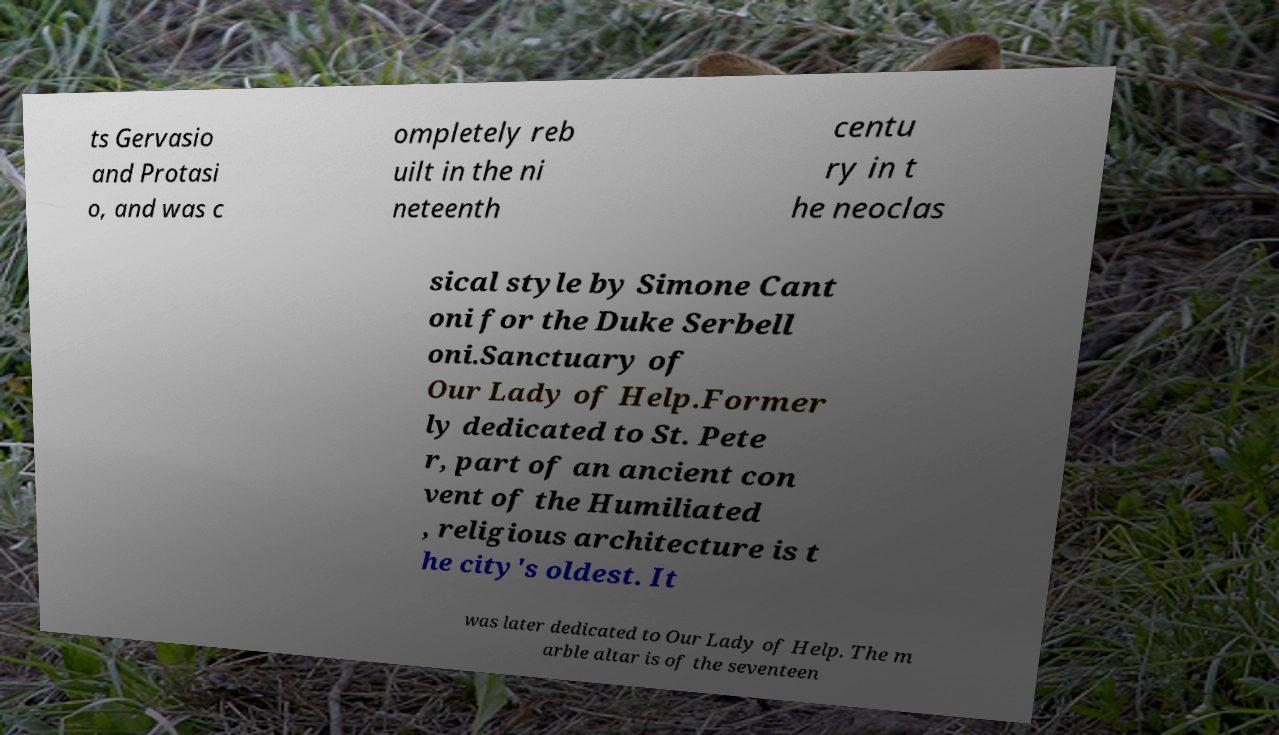What messages or text are displayed in this image? I need them in a readable, typed format. ts Gervasio and Protasi o, and was c ompletely reb uilt in the ni neteenth centu ry in t he neoclas sical style by Simone Cant oni for the Duke Serbell oni.Sanctuary of Our Lady of Help.Former ly dedicated to St. Pete r, part of an ancient con vent of the Humiliated , religious architecture is t he city's oldest. It was later dedicated to Our Lady of Help. The m arble altar is of the seventeen 